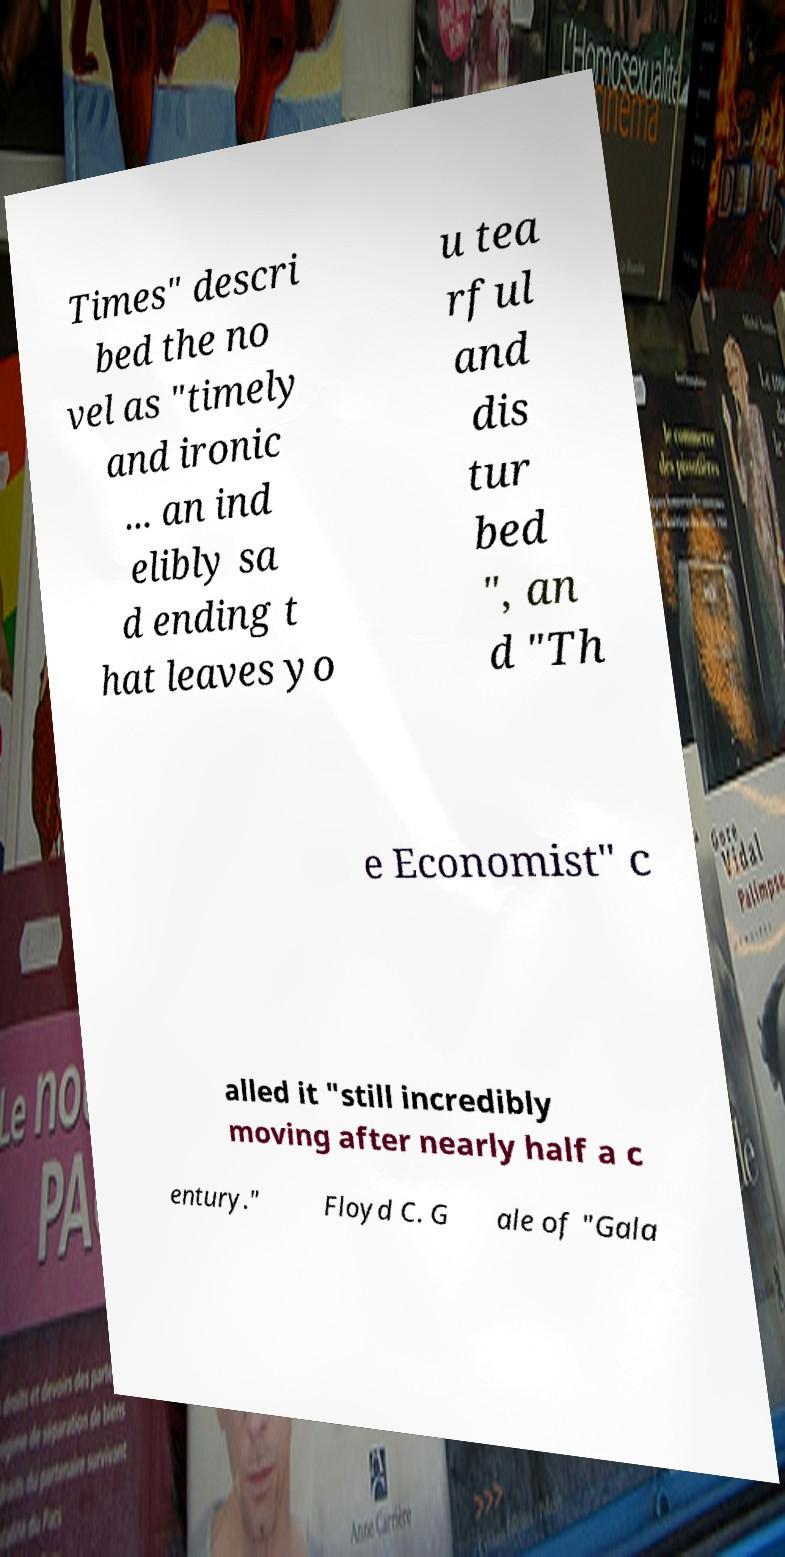Can you read and provide the text displayed in the image?This photo seems to have some interesting text. Can you extract and type it out for me? Times" descri bed the no vel as "timely and ironic ... an ind elibly sa d ending t hat leaves yo u tea rful and dis tur bed ", an d "Th e Economist" c alled it "still incredibly moving after nearly half a c entury." Floyd C. G ale of "Gala 